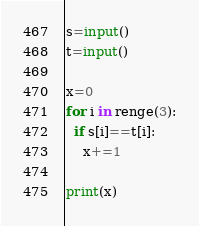Convert code to text. <code><loc_0><loc_0><loc_500><loc_500><_Python_>s=input()
t=input()

x=0
for i in renge(3):
  if s[i]==t[i]:
    x+=1
    
print(x)    
</code> 